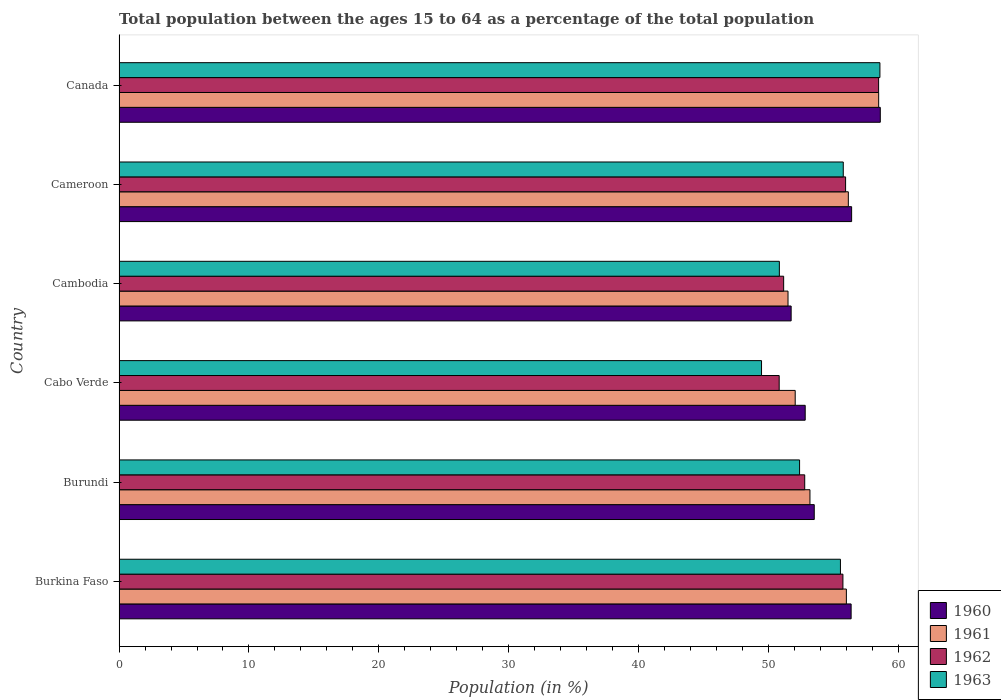How many different coloured bars are there?
Ensure brevity in your answer.  4. How many groups of bars are there?
Make the answer very short. 6. How many bars are there on the 3rd tick from the top?
Provide a succinct answer. 4. What is the label of the 1st group of bars from the top?
Offer a terse response. Canada. In how many cases, is the number of bars for a given country not equal to the number of legend labels?
Keep it short and to the point. 0. What is the percentage of the population ages 15 to 64 in 1963 in Burundi?
Keep it short and to the point. 52.38. Across all countries, what is the maximum percentage of the population ages 15 to 64 in 1963?
Your response must be concise. 58.57. Across all countries, what is the minimum percentage of the population ages 15 to 64 in 1961?
Give a very brief answer. 51.49. In which country was the percentage of the population ages 15 to 64 in 1960 minimum?
Your answer should be compact. Cambodia. What is the total percentage of the population ages 15 to 64 in 1960 in the graph?
Ensure brevity in your answer.  329.39. What is the difference between the percentage of the population ages 15 to 64 in 1962 in Burkina Faso and that in Burundi?
Your answer should be very brief. 2.94. What is the difference between the percentage of the population ages 15 to 64 in 1960 in Burundi and the percentage of the population ages 15 to 64 in 1962 in Cabo Verde?
Your response must be concise. 2.7. What is the average percentage of the population ages 15 to 64 in 1963 per country?
Provide a short and direct response. 53.75. What is the difference between the percentage of the population ages 15 to 64 in 1961 and percentage of the population ages 15 to 64 in 1960 in Canada?
Your answer should be compact. -0.13. In how many countries, is the percentage of the population ages 15 to 64 in 1961 greater than 20 ?
Your answer should be compact. 6. What is the ratio of the percentage of the population ages 15 to 64 in 1960 in Burkina Faso to that in Cambodia?
Offer a terse response. 1.09. What is the difference between the highest and the second highest percentage of the population ages 15 to 64 in 1960?
Provide a succinct answer. 2.21. What is the difference between the highest and the lowest percentage of the population ages 15 to 64 in 1962?
Provide a short and direct response. 7.65. Is it the case that in every country, the sum of the percentage of the population ages 15 to 64 in 1961 and percentage of the population ages 15 to 64 in 1963 is greater than the sum of percentage of the population ages 15 to 64 in 1962 and percentage of the population ages 15 to 64 in 1960?
Offer a very short reply. No. What does the 3rd bar from the top in Cambodia represents?
Make the answer very short. 1961. Are all the bars in the graph horizontal?
Make the answer very short. Yes. What is the difference between two consecutive major ticks on the X-axis?
Offer a terse response. 10. Are the values on the major ticks of X-axis written in scientific E-notation?
Your response must be concise. No. Where does the legend appear in the graph?
Your answer should be very brief. Bottom right. How many legend labels are there?
Your answer should be compact. 4. How are the legend labels stacked?
Your answer should be compact. Vertical. What is the title of the graph?
Your answer should be very brief. Total population between the ages 15 to 64 as a percentage of the total population. What is the label or title of the X-axis?
Give a very brief answer. Population (in %). What is the Population (in %) in 1960 in Burkina Faso?
Make the answer very short. 56.35. What is the Population (in %) in 1961 in Burkina Faso?
Make the answer very short. 55.98. What is the Population (in %) in 1962 in Burkina Faso?
Keep it short and to the point. 55.72. What is the Population (in %) in 1963 in Burkina Faso?
Your response must be concise. 55.53. What is the Population (in %) of 1960 in Burundi?
Keep it short and to the point. 53.51. What is the Population (in %) of 1961 in Burundi?
Your response must be concise. 53.18. What is the Population (in %) in 1962 in Burundi?
Your answer should be compact. 52.78. What is the Population (in %) in 1963 in Burundi?
Give a very brief answer. 52.38. What is the Population (in %) in 1960 in Cabo Verde?
Keep it short and to the point. 52.81. What is the Population (in %) in 1961 in Cabo Verde?
Make the answer very short. 52.04. What is the Population (in %) of 1962 in Cabo Verde?
Provide a succinct answer. 50.81. What is the Population (in %) in 1963 in Cabo Verde?
Offer a very short reply. 49.45. What is the Population (in %) of 1960 in Cambodia?
Your response must be concise. 51.73. What is the Population (in %) of 1961 in Cambodia?
Make the answer very short. 51.49. What is the Population (in %) of 1962 in Cambodia?
Ensure brevity in your answer.  51.16. What is the Population (in %) of 1963 in Cambodia?
Your answer should be very brief. 50.83. What is the Population (in %) in 1960 in Cameroon?
Ensure brevity in your answer.  56.39. What is the Population (in %) in 1961 in Cameroon?
Offer a terse response. 56.13. What is the Population (in %) in 1962 in Cameroon?
Your answer should be very brief. 55.92. What is the Population (in %) in 1963 in Cameroon?
Give a very brief answer. 55.74. What is the Population (in %) of 1960 in Canada?
Ensure brevity in your answer.  58.6. What is the Population (in %) of 1961 in Canada?
Offer a terse response. 58.47. What is the Population (in %) of 1962 in Canada?
Give a very brief answer. 58.47. What is the Population (in %) of 1963 in Canada?
Keep it short and to the point. 58.57. Across all countries, what is the maximum Population (in %) in 1960?
Provide a succinct answer. 58.6. Across all countries, what is the maximum Population (in %) in 1961?
Your answer should be compact. 58.47. Across all countries, what is the maximum Population (in %) of 1962?
Keep it short and to the point. 58.47. Across all countries, what is the maximum Population (in %) in 1963?
Ensure brevity in your answer.  58.57. Across all countries, what is the minimum Population (in %) in 1960?
Make the answer very short. 51.73. Across all countries, what is the minimum Population (in %) of 1961?
Keep it short and to the point. 51.49. Across all countries, what is the minimum Population (in %) of 1962?
Make the answer very short. 50.81. Across all countries, what is the minimum Population (in %) of 1963?
Give a very brief answer. 49.45. What is the total Population (in %) of 1960 in the graph?
Your answer should be very brief. 329.39. What is the total Population (in %) in 1961 in the graph?
Provide a short and direct response. 327.3. What is the total Population (in %) of 1962 in the graph?
Offer a very short reply. 324.85. What is the total Population (in %) in 1963 in the graph?
Keep it short and to the point. 322.5. What is the difference between the Population (in %) in 1960 in Burkina Faso and that in Burundi?
Your response must be concise. 2.84. What is the difference between the Population (in %) in 1961 in Burkina Faso and that in Burundi?
Offer a terse response. 2.8. What is the difference between the Population (in %) in 1962 in Burkina Faso and that in Burundi?
Offer a very short reply. 2.94. What is the difference between the Population (in %) of 1963 in Burkina Faso and that in Burundi?
Ensure brevity in your answer.  3.15. What is the difference between the Population (in %) in 1960 in Burkina Faso and that in Cabo Verde?
Your answer should be very brief. 3.53. What is the difference between the Population (in %) of 1961 in Burkina Faso and that in Cabo Verde?
Your answer should be very brief. 3.94. What is the difference between the Population (in %) of 1962 in Burkina Faso and that in Cabo Verde?
Provide a short and direct response. 4.91. What is the difference between the Population (in %) in 1963 in Burkina Faso and that in Cabo Verde?
Provide a succinct answer. 6.07. What is the difference between the Population (in %) in 1960 in Burkina Faso and that in Cambodia?
Provide a succinct answer. 4.62. What is the difference between the Population (in %) in 1961 in Burkina Faso and that in Cambodia?
Keep it short and to the point. 4.49. What is the difference between the Population (in %) of 1962 in Burkina Faso and that in Cambodia?
Offer a very short reply. 4.56. What is the difference between the Population (in %) of 1963 in Burkina Faso and that in Cambodia?
Ensure brevity in your answer.  4.7. What is the difference between the Population (in %) of 1960 in Burkina Faso and that in Cameroon?
Offer a terse response. -0.04. What is the difference between the Population (in %) in 1961 in Burkina Faso and that in Cameroon?
Your response must be concise. -0.15. What is the difference between the Population (in %) of 1962 in Burkina Faso and that in Cameroon?
Your response must be concise. -0.2. What is the difference between the Population (in %) in 1963 in Burkina Faso and that in Cameroon?
Offer a very short reply. -0.22. What is the difference between the Population (in %) of 1960 in Burkina Faso and that in Canada?
Your answer should be very brief. -2.25. What is the difference between the Population (in %) of 1961 in Burkina Faso and that in Canada?
Keep it short and to the point. -2.49. What is the difference between the Population (in %) in 1962 in Burkina Faso and that in Canada?
Ensure brevity in your answer.  -2.75. What is the difference between the Population (in %) in 1963 in Burkina Faso and that in Canada?
Ensure brevity in your answer.  -3.04. What is the difference between the Population (in %) of 1960 in Burundi and that in Cabo Verde?
Offer a very short reply. 0.7. What is the difference between the Population (in %) in 1961 in Burundi and that in Cabo Verde?
Your answer should be compact. 1.14. What is the difference between the Population (in %) of 1962 in Burundi and that in Cabo Verde?
Offer a very short reply. 1.96. What is the difference between the Population (in %) in 1963 in Burundi and that in Cabo Verde?
Make the answer very short. 2.93. What is the difference between the Population (in %) of 1960 in Burundi and that in Cambodia?
Offer a very short reply. 1.78. What is the difference between the Population (in %) of 1961 in Burundi and that in Cambodia?
Give a very brief answer. 1.69. What is the difference between the Population (in %) of 1962 in Burundi and that in Cambodia?
Your answer should be compact. 1.62. What is the difference between the Population (in %) in 1963 in Burundi and that in Cambodia?
Make the answer very short. 1.56. What is the difference between the Population (in %) of 1960 in Burundi and that in Cameroon?
Ensure brevity in your answer.  -2.88. What is the difference between the Population (in %) in 1961 in Burundi and that in Cameroon?
Your answer should be compact. -2.95. What is the difference between the Population (in %) of 1962 in Burundi and that in Cameroon?
Provide a succinct answer. -3.15. What is the difference between the Population (in %) in 1963 in Burundi and that in Cameroon?
Offer a terse response. -3.36. What is the difference between the Population (in %) of 1960 in Burundi and that in Canada?
Your answer should be very brief. -5.08. What is the difference between the Population (in %) in 1961 in Burundi and that in Canada?
Offer a terse response. -5.29. What is the difference between the Population (in %) in 1962 in Burundi and that in Canada?
Keep it short and to the point. -5.69. What is the difference between the Population (in %) in 1963 in Burundi and that in Canada?
Make the answer very short. -6.18. What is the difference between the Population (in %) of 1960 in Cabo Verde and that in Cambodia?
Offer a very short reply. 1.08. What is the difference between the Population (in %) in 1961 in Cabo Verde and that in Cambodia?
Your answer should be very brief. 0.55. What is the difference between the Population (in %) of 1962 in Cabo Verde and that in Cambodia?
Offer a very short reply. -0.34. What is the difference between the Population (in %) in 1963 in Cabo Verde and that in Cambodia?
Your answer should be very brief. -1.37. What is the difference between the Population (in %) of 1960 in Cabo Verde and that in Cameroon?
Give a very brief answer. -3.57. What is the difference between the Population (in %) in 1961 in Cabo Verde and that in Cameroon?
Keep it short and to the point. -4.09. What is the difference between the Population (in %) of 1962 in Cabo Verde and that in Cameroon?
Your answer should be very brief. -5.11. What is the difference between the Population (in %) of 1963 in Cabo Verde and that in Cameroon?
Keep it short and to the point. -6.29. What is the difference between the Population (in %) in 1960 in Cabo Verde and that in Canada?
Ensure brevity in your answer.  -5.78. What is the difference between the Population (in %) of 1961 in Cabo Verde and that in Canada?
Keep it short and to the point. -6.43. What is the difference between the Population (in %) of 1962 in Cabo Verde and that in Canada?
Make the answer very short. -7.65. What is the difference between the Population (in %) in 1963 in Cabo Verde and that in Canada?
Your answer should be very brief. -9.11. What is the difference between the Population (in %) of 1960 in Cambodia and that in Cameroon?
Your answer should be compact. -4.66. What is the difference between the Population (in %) in 1961 in Cambodia and that in Cameroon?
Make the answer very short. -4.64. What is the difference between the Population (in %) of 1962 in Cambodia and that in Cameroon?
Keep it short and to the point. -4.77. What is the difference between the Population (in %) of 1963 in Cambodia and that in Cameroon?
Provide a short and direct response. -4.92. What is the difference between the Population (in %) in 1960 in Cambodia and that in Canada?
Keep it short and to the point. -6.86. What is the difference between the Population (in %) of 1961 in Cambodia and that in Canada?
Give a very brief answer. -6.98. What is the difference between the Population (in %) in 1962 in Cambodia and that in Canada?
Offer a terse response. -7.31. What is the difference between the Population (in %) of 1963 in Cambodia and that in Canada?
Provide a succinct answer. -7.74. What is the difference between the Population (in %) of 1960 in Cameroon and that in Canada?
Offer a very short reply. -2.21. What is the difference between the Population (in %) of 1961 in Cameroon and that in Canada?
Your response must be concise. -2.34. What is the difference between the Population (in %) of 1962 in Cameroon and that in Canada?
Offer a terse response. -2.54. What is the difference between the Population (in %) in 1963 in Cameroon and that in Canada?
Your response must be concise. -2.82. What is the difference between the Population (in %) of 1960 in Burkina Faso and the Population (in %) of 1961 in Burundi?
Your answer should be compact. 3.17. What is the difference between the Population (in %) of 1960 in Burkina Faso and the Population (in %) of 1962 in Burundi?
Your answer should be compact. 3.57. What is the difference between the Population (in %) of 1960 in Burkina Faso and the Population (in %) of 1963 in Burundi?
Ensure brevity in your answer.  3.97. What is the difference between the Population (in %) of 1961 in Burkina Faso and the Population (in %) of 1962 in Burundi?
Provide a succinct answer. 3.21. What is the difference between the Population (in %) of 1961 in Burkina Faso and the Population (in %) of 1963 in Burundi?
Keep it short and to the point. 3.6. What is the difference between the Population (in %) of 1962 in Burkina Faso and the Population (in %) of 1963 in Burundi?
Make the answer very short. 3.34. What is the difference between the Population (in %) in 1960 in Burkina Faso and the Population (in %) in 1961 in Cabo Verde?
Offer a very short reply. 4.3. What is the difference between the Population (in %) in 1960 in Burkina Faso and the Population (in %) in 1962 in Cabo Verde?
Give a very brief answer. 5.54. What is the difference between the Population (in %) in 1960 in Burkina Faso and the Population (in %) in 1963 in Cabo Verde?
Offer a terse response. 6.9. What is the difference between the Population (in %) in 1961 in Burkina Faso and the Population (in %) in 1962 in Cabo Verde?
Offer a very short reply. 5.17. What is the difference between the Population (in %) in 1961 in Burkina Faso and the Population (in %) in 1963 in Cabo Verde?
Provide a succinct answer. 6.53. What is the difference between the Population (in %) of 1962 in Burkina Faso and the Population (in %) of 1963 in Cabo Verde?
Keep it short and to the point. 6.26. What is the difference between the Population (in %) of 1960 in Burkina Faso and the Population (in %) of 1961 in Cambodia?
Ensure brevity in your answer.  4.86. What is the difference between the Population (in %) in 1960 in Burkina Faso and the Population (in %) in 1962 in Cambodia?
Offer a terse response. 5.19. What is the difference between the Population (in %) in 1960 in Burkina Faso and the Population (in %) in 1963 in Cambodia?
Give a very brief answer. 5.52. What is the difference between the Population (in %) of 1961 in Burkina Faso and the Population (in %) of 1962 in Cambodia?
Offer a terse response. 4.83. What is the difference between the Population (in %) of 1961 in Burkina Faso and the Population (in %) of 1963 in Cambodia?
Your answer should be very brief. 5.16. What is the difference between the Population (in %) in 1962 in Burkina Faso and the Population (in %) in 1963 in Cambodia?
Your answer should be compact. 4.89. What is the difference between the Population (in %) in 1960 in Burkina Faso and the Population (in %) in 1961 in Cameroon?
Your answer should be compact. 0.21. What is the difference between the Population (in %) of 1960 in Burkina Faso and the Population (in %) of 1962 in Cameroon?
Your answer should be very brief. 0.43. What is the difference between the Population (in %) in 1960 in Burkina Faso and the Population (in %) in 1963 in Cameroon?
Provide a short and direct response. 0.6. What is the difference between the Population (in %) in 1961 in Burkina Faso and the Population (in %) in 1962 in Cameroon?
Your answer should be very brief. 0.06. What is the difference between the Population (in %) of 1961 in Burkina Faso and the Population (in %) of 1963 in Cameroon?
Your answer should be compact. 0.24. What is the difference between the Population (in %) in 1962 in Burkina Faso and the Population (in %) in 1963 in Cameroon?
Make the answer very short. -0.03. What is the difference between the Population (in %) of 1960 in Burkina Faso and the Population (in %) of 1961 in Canada?
Your answer should be compact. -2.12. What is the difference between the Population (in %) of 1960 in Burkina Faso and the Population (in %) of 1962 in Canada?
Your response must be concise. -2.12. What is the difference between the Population (in %) of 1960 in Burkina Faso and the Population (in %) of 1963 in Canada?
Ensure brevity in your answer.  -2.22. What is the difference between the Population (in %) in 1961 in Burkina Faso and the Population (in %) in 1962 in Canada?
Keep it short and to the point. -2.48. What is the difference between the Population (in %) of 1961 in Burkina Faso and the Population (in %) of 1963 in Canada?
Provide a succinct answer. -2.58. What is the difference between the Population (in %) in 1962 in Burkina Faso and the Population (in %) in 1963 in Canada?
Provide a succinct answer. -2.85. What is the difference between the Population (in %) of 1960 in Burundi and the Population (in %) of 1961 in Cabo Verde?
Give a very brief answer. 1.47. What is the difference between the Population (in %) of 1960 in Burundi and the Population (in %) of 1962 in Cabo Verde?
Provide a succinct answer. 2.7. What is the difference between the Population (in %) in 1960 in Burundi and the Population (in %) in 1963 in Cabo Verde?
Offer a terse response. 4.06. What is the difference between the Population (in %) of 1961 in Burundi and the Population (in %) of 1962 in Cabo Verde?
Offer a very short reply. 2.37. What is the difference between the Population (in %) in 1961 in Burundi and the Population (in %) in 1963 in Cabo Verde?
Your response must be concise. 3.73. What is the difference between the Population (in %) of 1962 in Burundi and the Population (in %) of 1963 in Cabo Verde?
Your response must be concise. 3.32. What is the difference between the Population (in %) of 1960 in Burundi and the Population (in %) of 1961 in Cambodia?
Your answer should be very brief. 2.02. What is the difference between the Population (in %) in 1960 in Burundi and the Population (in %) in 1962 in Cambodia?
Offer a terse response. 2.36. What is the difference between the Population (in %) of 1960 in Burundi and the Population (in %) of 1963 in Cambodia?
Keep it short and to the point. 2.69. What is the difference between the Population (in %) in 1961 in Burundi and the Population (in %) in 1962 in Cambodia?
Provide a succinct answer. 2.02. What is the difference between the Population (in %) of 1961 in Burundi and the Population (in %) of 1963 in Cambodia?
Give a very brief answer. 2.35. What is the difference between the Population (in %) in 1962 in Burundi and the Population (in %) in 1963 in Cambodia?
Provide a succinct answer. 1.95. What is the difference between the Population (in %) in 1960 in Burundi and the Population (in %) in 1961 in Cameroon?
Keep it short and to the point. -2.62. What is the difference between the Population (in %) of 1960 in Burundi and the Population (in %) of 1962 in Cameroon?
Your response must be concise. -2.41. What is the difference between the Population (in %) of 1960 in Burundi and the Population (in %) of 1963 in Cameroon?
Ensure brevity in your answer.  -2.23. What is the difference between the Population (in %) in 1961 in Burundi and the Population (in %) in 1962 in Cameroon?
Keep it short and to the point. -2.74. What is the difference between the Population (in %) of 1961 in Burundi and the Population (in %) of 1963 in Cameroon?
Make the answer very short. -2.56. What is the difference between the Population (in %) in 1962 in Burundi and the Population (in %) in 1963 in Cameroon?
Provide a short and direct response. -2.97. What is the difference between the Population (in %) in 1960 in Burundi and the Population (in %) in 1961 in Canada?
Your response must be concise. -4.96. What is the difference between the Population (in %) in 1960 in Burundi and the Population (in %) in 1962 in Canada?
Your answer should be compact. -4.95. What is the difference between the Population (in %) of 1960 in Burundi and the Population (in %) of 1963 in Canada?
Make the answer very short. -5.05. What is the difference between the Population (in %) of 1961 in Burundi and the Population (in %) of 1962 in Canada?
Make the answer very short. -5.29. What is the difference between the Population (in %) of 1961 in Burundi and the Population (in %) of 1963 in Canada?
Give a very brief answer. -5.39. What is the difference between the Population (in %) of 1962 in Burundi and the Population (in %) of 1963 in Canada?
Make the answer very short. -5.79. What is the difference between the Population (in %) of 1960 in Cabo Verde and the Population (in %) of 1961 in Cambodia?
Offer a very short reply. 1.32. What is the difference between the Population (in %) of 1960 in Cabo Verde and the Population (in %) of 1962 in Cambodia?
Offer a terse response. 1.66. What is the difference between the Population (in %) in 1960 in Cabo Verde and the Population (in %) in 1963 in Cambodia?
Offer a terse response. 1.99. What is the difference between the Population (in %) in 1961 in Cabo Verde and the Population (in %) in 1962 in Cambodia?
Offer a very short reply. 0.89. What is the difference between the Population (in %) in 1961 in Cabo Verde and the Population (in %) in 1963 in Cambodia?
Keep it short and to the point. 1.22. What is the difference between the Population (in %) of 1962 in Cabo Verde and the Population (in %) of 1963 in Cambodia?
Offer a very short reply. -0.01. What is the difference between the Population (in %) in 1960 in Cabo Verde and the Population (in %) in 1961 in Cameroon?
Provide a succinct answer. -3.32. What is the difference between the Population (in %) in 1960 in Cabo Verde and the Population (in %) in 1962 in Cameroon?
Offer a very short reply. -3.11. What is the difference between the Population (in %) of 1960 in Cabo Verde and the Population (in %) of 1963 in Cameroon?
Your answer should be very brief. -2.93. What is the difference between the Population (in %) of 1961 in Cabo Verde and the Population (in %) of 1962 in Cameroon?
Give a very brief answer. -3.88. What is the difference between the Population (in %) of 1961 in Cabo Verde and the Population (in %) of 1963 in Cameroon?
Offer a terse response. -3.7. What is the difference between the Population (in %) in 1962 in Cabo Verde and the Population (in %) in 1963 in Cameroon?
Offer a terse response. -4.93. What is the difference between the Population (in %) in 1960 in Cabo Verde and the Population (in %) in 1961 in Canada?
Your answer should be compact. -5.65. What is the difference between the Population (in %) of 1960 in Cabo Verde and the Population (in %) of 1962 in Canada?
Keep it short and to the point. -5.65. What is the difference between the Population (in %) in 1960 in Cabo Verde and the Population (in %) in 1963 in Canada?
Your response must be concise. -5.75. What is the difference between the Population (in %) of 1961 in Cabo Verde and the Population (in %) of 1962 in Canada?
Give a very brief answer. -6.42. What is the difference between the Population (in %) of 1961 in Cabo Verde and the Population (in %) of 1963 in Canada?
Provide a succinct answer. -6.52. What is the difference between the Population (in %) in 1962 in Cabo Verde and the Population (in %) in 1963 in Canada?
Your answer should be very brief. -7.75. What is the difference between the Population (in %) in 1960 in Cambodia and the Population (in %) in 1961 in Cameroon?
Offer a terse response. -4.4. What is the difference between the Population (in %) in 1960 in Cambodia and the Population (in %) in 1962 in Cameroon?
Your answer should be compact. -4.19. What is the difference between the Population (in %) in 1960 in Cambodia and the Population (in %) in 1963 in Cameroon?
Your answer should be very brief. -4.01. What is the difference between the Population (in %) in 1961 in Cambodia and the Population (in %) in 1962 in Cameroon?
Your answer should be compact. -4.43. What is the difference between the Population (in %) in 1961 in Cambodia and the Population (in %) in 1963 in Cameroon?
Ensure brevity in your answer.  -4.25. What is the difference between the Population (in %) in 1962 in Cambodia and the Population (in %) in 1963 in Cameroon?
Offer a terse response. -4.59. What is the difference between the Population (in %) in 1960 in Cambodia and the Population (in %) in 1961 in Canada?
Your answer should be very brief. -6.74. What is the difference between the Population (in %) of 1960 in Cambodia and the Population (in %) of 1962 in Canada?
Ensure brevity in your answer.  -6.73. What is the difference between the Population (in %) in 1960 in Cambodia and the Population (in %) in 1963 in Canada?
Keep it short and to the point. -6.83. What is the difference between the Population (in %) of 1961 in Cambodia and the Population (in %) of 1962 in Canada?
Offer a very short reply. -6.97. What is the difference between the Population (in %) in 1961 in Cambodia and the Population (in %) in 1963 in Canada?
Provide a succinct answer. -7.07. What is the difference between the Population (in %) in 1962 in Cambodia and the Population (in %) in 1963 in Canada?
Provide a short and direct response. -7.41. What is the difference between the Population (in %) in 1960 in Cameroon and the Population (in %) in 1961 in Canada?
Give a very brief answer. -2.08. What is the difference between the Population (in %) in 1960 in Cameroon and the Population (in %) in 1962 in Canada?
Ensure brevity in your answer.  -2.08. What is the difference between the Population (in %) in 1960 in Cameroon and the Population (in %) in 1963 in Canada?
Offer a very short reply. -2.18. What is the difference between the Population (in %) of 1961 in Cameroon and the Population (in %) of 1962 in Canada?
Make the answer very short. -2.33. What is the difference between the Population (in %) of 1961 in Cameroon and the Population (in %) of 1963 in Canada?
Your response must be concise. -2.43. What is the difference between the Population (in %) of 1962 in Cameroon and the Population (in %) of 1963 in Canada?
Your response must be concise. -2.64. What is the average Population (in %) of 1960 per country?
Make the answer very short. 54.9. What is the average Population (in %) in 1961 per country?
Ensure brevity in your answer.  54.55. What is the average Population (in %) in 1962 per country?
Offer a very short reply. 54.14. What is the average Population (in %) of 1963 per country?
Your response must be concise. 53.75. What is the difference between the Population (in %) of 1960 and Population (in %) of 1961 in Burkina Faso?
Your answer should be compact. 0.37. What is the difference between the Population (in %) of 1960 and Population (in %) of 1962 in Burkina Faso?
Provide a short and direct response. 0.63. What is the difference between the Population (in %) of 1960 and Population (in %) of 1963 in Burkina Faso?
Your answer should be very brief. 0.82. What is the difference between the Population (in %) in 1961 and Population (in %) in 1962 in Burkina Faso?
Offer a very short reply. 0.26. What is the difference between the Population (in %) of 1961 and Population (in %) of 1963 in Burkina Faso?
Offer a very short reply. 0.46. What is the difference between the Population (in %) of 1962 and Population (in %) of 1963 in Burkina Faso?
Keep it short and to the point. 0.19. What is the difference between the Population (in %) of 1960 and Population (in %) of 1961 in Burundi?
Give a very brief answer. 0.33. What is the difference between the Population (in %) in 1960 and Population (in %) in 1962 in Burundi?
Your answer should be very brief. 0.73. What is the difference between the Population (in %) of 1960 and Population (in %) of 1963 in Burundi?
Keep it short and to the point. 1.13. What is the difference between the Population (in %) in 1961 and Population (in %) in 1962 in Burundi?
Your answer should be very brief. 0.4. What is the difference between the Population (in %) of 1961 and Population (in %) of 1963 in Burundi?
Offer a terse response. 0.8. What is the difference between the Population (in %) of 1962 and Population (in %) of 1963 in Burundi?
Keep it short and to the point. 0.4. What is the difference between the Population (in %) of 1960 and Population (in %) of 1961 in Cabo Verde?
Your answer should be very brief. 0.77. What is the difference between the Population (in %) of 1960 and Population (in %) of 1962 in Cabo Verde?
Offer a terse response. 2. What is the difference between the Population (in %) in 1960 and Population (in %) in 1963 in Cabo Verde?
Your response must be concise. 3.36. What is the difference between the Population (in %) of 1961 and Population (in %) of 1962 in Cabo Verde?
Give a very brief answer. 1.23. What is the difference between the Population (in %) in 1961 and Population (in %) in 1963 in Cabo Verde?
Your response must be concise. 2.59. What is the difference between the Population (in %) of 1962 and Population (in %) of 1963 in Cabo Verde?
Your response must be concise. 1.36. What is the difference between the Population (in %) in 1960 and Population (in %) in 1961 in Cambodia?
Your answer should be compact. 0.24. What is the difference between the Population (in %) in 1960 and Population (in %) in 1962 in Cambodia?
Your response must be concise. 0.58. What is the difference between the Population (in %) of 1960 and Population (in %) of 1963 in Cambodia?
Offer a terse response. 0.91. What is the difference between the Population (in %) in 1961 and Population (in %) in 1962 in Cambodia?
Provide a succinct answer. 0.34. What is the difference between the Population (in %) in 1961 and Population (in %) in 1963 in Cambodia?
Make the answer very short. 0.67. What is the difference between the Population (in %) of 1962 and Population (in %) of 1963 in Cambodia?
Give a very brief answer. 0.33. What is the difference between the Population (in %) in 1960 and Population (in %) in 1961 in Cameroon?
Offer a terse response. 0.25. What is the difference between the Population (in %) in 1960 and Population (in %) in 1962 in Cameroon?
Your response must be concise. 0.46. What is the difference between the Population (in %) in 1960 and Population (in %) in 1963 in Cameroon?
Your answer should be very brief. 0.64. What is the difference between the Population (in %) in 1961 and Population (in %) in 1962 in Cameroon?
Your answer should be very brief. 0.21. What is the difference between the Population (in %) in 1961 and Population (in %) in 1963 in Cameroon?
Make the answer very short. 0.39. What is the difference between the Population (in %) of 1962 and Population (in %) of 1963 in Cameroon?
Offer a terse response. 0.18. What is the difference between the Population (in %) of 1960 and Population (in %) of 1961 in Canada?
Your answer should be compact. 0.13. What is the difference between the Population (in %) of 1960 and Population (in %) of 1962 in Canada?
Your response must be concise. 0.13. What is the difference between the Population (in %) of 1960 and Population (in %) of 1963 in Canada?
Ensure brevity in your answer.  0.03. What is the difference between the Population (in %) in 1961 and Population (in %) in 1962 in Canada?
Your response must be concise. 0. What is the difference between the Population (in %) in 1961 and Population (in %) in 1963 in Canada?
Offer a very short reply. -0.1. What is the difference between the Population (in %) of 1962 and Population (in %) of 1963 in Canada?
Offer a terse response. -0.1. What is the ratio of the Population (in %) of 1960 in Burkina Faso to that in Burundi?
Your answer should be compact. 1.05. What is the ratio of the Population (in %) of 1961 in Burkina Faso to that in Burundi?
Provide a succinct answer. 1.05. What is the ratio of the Population (in %) in 1962 in Burkina Faso to that in Burundi?
Provide a succinct answer. 1.06. What is the ratio of the Population (in %) of 1963 in Burkina Faso to that in Burundi?
Provide a succinct answer. 1.06. What is the ratio of the Population (in %) in 1960 in Burkina Faso to that in Cabo Verde?
Ensure brevity in your answer.  1.07. What is the ratio of the Population (in %) of 1961 in Burkina Faso to that in Cabo Verde?
Ensure brevity in your answer.  1.08. What is the ratio of the Population (in %) of 1962 in Burkina Faso to that in Cabo Verde?
Offer a very short reply. 1.1. What is the ratio of the Population (in %) of 1963 in Burkina Faso to that in Cabo Verde?
Provide a short and direct response. 1.12. What is the ratio of the Population (in %) of 1960 in Burkina Faso to that in Cambodia?
Offer a very short reply. 1.09. What is the ratio of the Population (in %) of 1961 in Burkina Faso to that in Cambodia?
Provide a succinct answer. 1.09. What is the ratio of the Population (in %) of 1962 in Burkina Faso to that in Cambodia?
Your answer should be very brief. 1.09. What is the ratio of the Population (in %) in 1963 in Burkina Faso to that in Cambodia?
Offer a very short reply. 1.09. What is the ratio of the Population (in %) of 1961 in Burkina Faso to that in Cameroon?
Give a very brief answer. 1. What is the ratio of the Population (in %) of 1960 in Burkina Faso to that in Canada?
Keep it short and to the point. 0.96. What is the ratio of the Population (in %) of 1961 in Burkina Faso to that in Canada?
Provide a short and direct response. 0.96. What is the ratio of the Population (in %) in 1962 in Burkina Faso to that in Canada?
Offer a very short reply. 0.95. What is the ratio of the Population (in %) of 1963 in Burkina Faso to that in Canada?
Make the answer very short. 0.95. What is the ratio of the Population (in %) in 1960 in Burundi to that in Cabo Verde?
Provide a succinct answer. 1.01. What is the ratio of the Population (in %) of 1961 in Burundi to that in Cabo Verde?
Offer a very short reply. 1.02. What is the ratio of the Population (in %) in 1962 in Burundi to that in Cabo Verde?
Your answer should be very brief. 1.04. What is the ratio of the Population (in %) of 1963 in Burundi to that in Cabo Verde?
Ensure brevity in your answer.  1.06. What is the ratio of the Population (in %) in 1960 in Burundi to that in Cambodia?
Provide a succinct answer. 1.03. What is the ratio of the Population (in %) in 1961 in Burundi to that in Cambodia?
Offer a terse response. 1.03. What is the ratio of the Population (in %) in 1962 in Burundi to that in Cambodia?
Your answer should be very brief. 1.03. What is the ratio of the Population (in %) of 1963 in Burundi to that in Cambodia?
Make the answer very short. 1.03. What is the ratio of the Population (in %) in 1960 in Burundi to that in Cameroon?
Provide a succinct answer. 0.95. What is the ratio of the Population (in %) in 1961 in Burundi to that in Cameroon?
Keep it short and to the point. 0.95. What is the ratio of the Population (in %) in 1962 in Burundi to that in Cameroon?
Your answer should be very brief. 0.94. What is the ratio of the Population (in %) in 1963 in Burundi to that in Cameroon?
Offer a terse response. 0.94. What is the ratio of the Population (in %) in 1960 in Burundi to that in Canada?
Offer a terse response. 0.91. What is the ratio of the Population (in %) of 1961 in Burundi to that in Canada?
Provide a succinct answer. 0.91. What is the ratio of the Population (in %) in 1962 in Burundi to that in Canada?
Your answer should be very brief. 0.9. What is the ratio of the Population (in %) in 1963 in Burundi to that in Canada?
Provide a short and direct response. 0.89. What is the ratio of the Population (in %) of 1960 in Cabo Verde to that in Cambodia?
Your response must be concise. 1.02. What is the ratio of the Population (in %) in 1961 in Cabo Verde to that in Cambodia?
Give a very brief answer. 1.01. What is the ratio of the Population (in %) in 1963 in Cabo Verde to that in Cambodia?
Your response must be concise. 0.97. What is the ratio of the Population (in %) of 1960 in Cabo Verde to that in Cameroon?
Your response must be concise. 0.94. What is the ratio of the Population (in %) of 1961 in Cabo Verde to that in Cameroon?
Your answer should be compact. 0.93. What is the ratio of the Population (in %) of 1962 in Cabo Verde to that in Cameroon?
Keep it short and to the point. 0.91. What is the ratio of the Population (in %) of 1963 in Cabo Verde to that in Cameroon?
Give a very brief answer. 0.89. What is the ratio of the Population (in %) in 1960 in Cabo Verde to that in Canada?
Offer a very short reply. 0.9. What is the ratio of the Population (in %) in 1961 in Cabo Verde to that in Canada?
Offer a terse response. 0.89. What is the ratio of the Population (in %) in 1962 in Cabo Verde to that in Canada?
Your response must be concise. 0.87. What is the ratio of the Population (in %) in 1963 in Cabo Verde to that in Canada?
Your answer should be very brief. 0.84. What is the ratio of the Population (in %) of 1960 in Cambodia to that in Cameroon?
Ensure brevity in your answer.  0.92. What is the ratio of the Population (in %) in 1961 in Cambodia to that in Cameroon?
Offer a terse response. 0.92. What is the ratio of the Population (in %) of 1962 in Cambodia to that in Cameroon?
Your answer should be very brief. 0.91. What is the ratio of the Population (in %) in 1963 in Cambodia to that in Cameroon?
Your answer should be compact. 0.91. What is the ratio of the Population (in %) in 1960 in Cambodia to that in Canada?
Keep it short and to the point. 0.88. What is the ratio of the Population (in %) in 1961 in Cambodia to that in Canada?
Your response must be concise. 0.88. What is the ratio of the Population (in %) in 1963 in Cambodia to that in Canada?
Make the answer very short. 0.87. What is the ratio of the Population (in %) of 1960 in Cameroon to that in Canada?
Provide a succinct answer. 0.96. What is the ratio of the Population (in %) in 1961 in Cameroon to that in Canada?
Keep it short and to the point. 0.96. What is the ratio of the Population (in %) in 1962 in Cameroon to that in Canada?
Offer a very short reply. 0.96. What is the ratio of the Population (in %) in 1963 in Cameroon to that in Canada?
Ensure brevity in your answer.  0.95. What is the difference between the highest and the second highest Population (in %) in 1960?
Provide a short and direct response. 2.21. What is the difference between the highest and the second highest Population (in %) of 1961?
Offer a very short reply. 2.34. What is the difference between the highest and the second highest Population (in %) of 1962?
Provide a succinct answer. 2.54. What is the difference between the highest and the second highest Population (in %) in 1963?
Give a very brief answer. 2.82. What is the difference between the highest and the lowest Population (in %) in 1960?
Your answer should be very brief. 6.86. What is the difference between the highest and the lowest Population (in %) in 1961?
Provide a succinct answer. 6.98. What is the difference between the highest and the lowest Population (in %) in 1962?
Your answer should be compact. 7.65. What is the difference between the highest and the lowest Population (in %) in 1963?
Give a very brief answer. 9.11. 